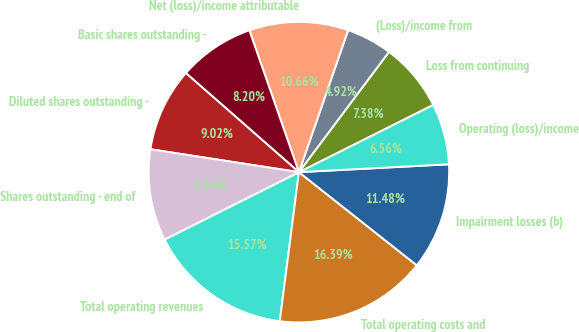Convert chart to OTSL. <chart><loc_0><loc_0><loc_500><loc_500><pie_chart><fcel>Total operating revenues<fcel>Total operating costs and<fcel>Impairment losses (b)<fcel>Operating (loss)/income<fcel>Loss from continuing<fcel>(Loss)/income from<fcel>Net (loss)/income attributable<fcel>Basic shares outstanding -<fcel>Diluted shares outstanding -<fcel>Shares outstanding - end of<nl><fcel>15.57%<fcel>16.39%<fcel>11.48%<fcel>6.56%<fcel>7.38%<fcel>4.92%<fcel>10.66%<fcel>8.2%<fcel>9.02%<fcel>9.84%<nl></chart> 